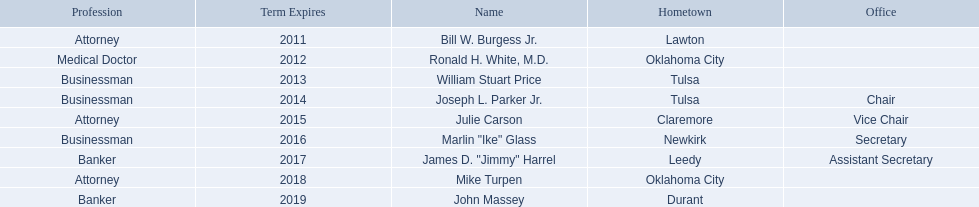What businessmen were born in tulsa? William Stuart Price, Joseph L. Parker Jr. Which man, other than price, was born in tulsa? Joseph L. Parker Jr. Would you mind parsing the complete table? {'header': ['Profession', 'Term Expires', 'Name', 'Hometown', 'Office'], 'rows': [['Attorney', '2011', 'Bill W. Burgess Jr.', 'Lawton', ''], ['Medical Doctor', '2012', 'Ronald H. White, M.D.', 'Oklahoma City', ''], ['Businessman', '2013', 'William Stuart Price', 'Tulsa', ''], ['Businessman', '2014', 'Joseph L. Parker Jr.', 'Tulsa', 'Chair'], ['Attorney', '2015', 'Julie Carson', 'Claremore', 'Vice Chair'], ['Businessman', '2016', 'Marlin "Ike" Glass', 'Newkirk', 'Secretary'], ['Banker', '2017', 'James D. "Jimmy" Harrel', 'Leedy', 'Assistant Secretary'], ['Attorney', '2018', 'Mike Turpen', 'Oklahoma City', ''], ['Banker', '2019', 'John Massey', 'Durant', '']]} 